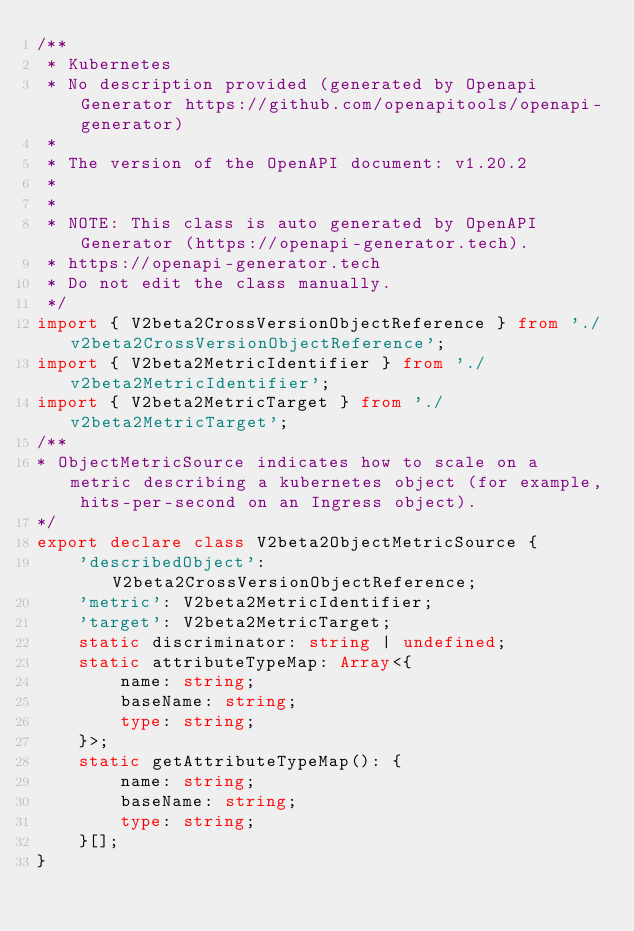<code> <loc_0><loc_0><loc_500><loc_500><_TypeScript_>/**
 * Kubernetes
 * No description provided (generated by Openapi Generator https://github.com/openapitools/openapi-generator)
 *
 * The version of the OpenAPI document: v1.20.2
 *
 *
 * NOTE: This class is auto generated by OpenAPI Generator (https://openapi-generator.tech).
 * https://openapi-generator.tech
 * Do not edit the class manually.
 */
import { V2beta2CrossVersionObjectReference } from './v2beta2CrossVersionObjectReference';
import { V2beta2MetricIdentifier } from './v2beta2MetricIdentifier';
import { V2beta2MetricTarget } from './v2beta2MetricTarget';
/**
* ObjectMetricSource indicates how to scale on a metric describing a kubernetes object (for example, hits-per-second on an Ingress object).
*/
export declare class V2beta2ObjectMetricSource {
    'describedObject': V2beta2CrossVersionObjectReference;
    'metric': V2beta2MetricIdentifier;
    'target': V2beta2MetricTarget;
    static discriminator: string | undefined;
    static attributeTypeMap: Array<{
        name: string;
        baseName: string;
        type: string;
    }>;
    static getAttributeTypeMap(): {
        name: string;
        baseName: string;
        type: string;
    }[];
}
</code> 